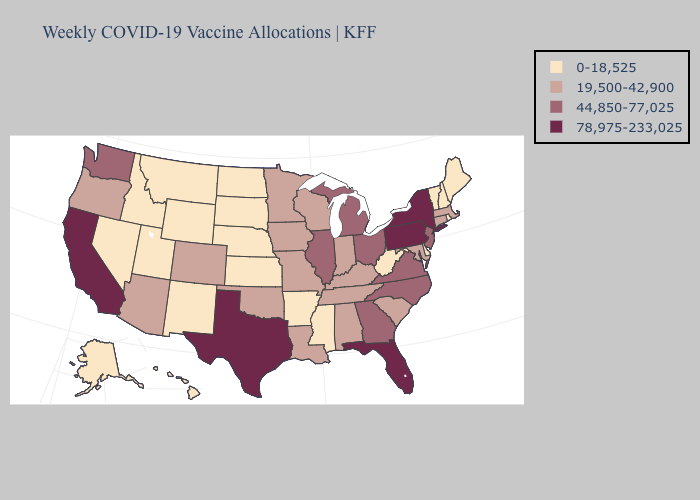How many symbols are there in the legend?
Concise answer only. 4. Name the states that have a value in the range 0-18,525?
Be succinct. Alaska, Arkansas, Delaware, Hawaii, Idaho, Kansas, Maine, Mississippi, Montana, Nebraska, Nevada, New Hampshire, New Mexico, North Dakota, Rhode Island, South Dakota, Utah, Vermont, West Virginia, Wyoming. Does Mississippi have the highest value in the USA?
Short answer required. No. Does Alabama have a higher value than Massachusetts?
Keep it brief. No. Name the states that have a value in the range 19,500-42,900?
Short answer required. Alabama, Arizona, Colorado, Connecticut, Indiana, Iowa, Kentucky, Louisiana, Maryland, Massachusetts, Minnesota, Missouri, Oklahoma, Oregon, South Carolina, Tennessee, Wisconsin. What is the value of Virginia?
Give a very brief answer. 44,850-77,025. What is the value of Illinois?
Write a very short answer. 44,850-77,025. Does New Jersey have the lowest value in the USA?
Short answer required. No. What is the value of Oregon?
Write a very short answer. 19,500-42,900. What is the value of Mississippi?
Quick response, please. 0-18,525. Among the states that border Mississippi , does Arkansas have the highest value?
Answer briefly. No. Among the states that border Wyoming , does Colorado have the highest value?
Keep it brief. Yes. What is the highest value in the USA?
Concise answer only. 78,975-233,025. Does Ohio have the lowest value in the USA?
Keep it brief. No. Name the states that have a value in the range 44,850-77,025?
Give a very brief answer. Georgia, Illinois, Michigan, New Jersey, North Carolina, Ohio, Virginia, Washington. 